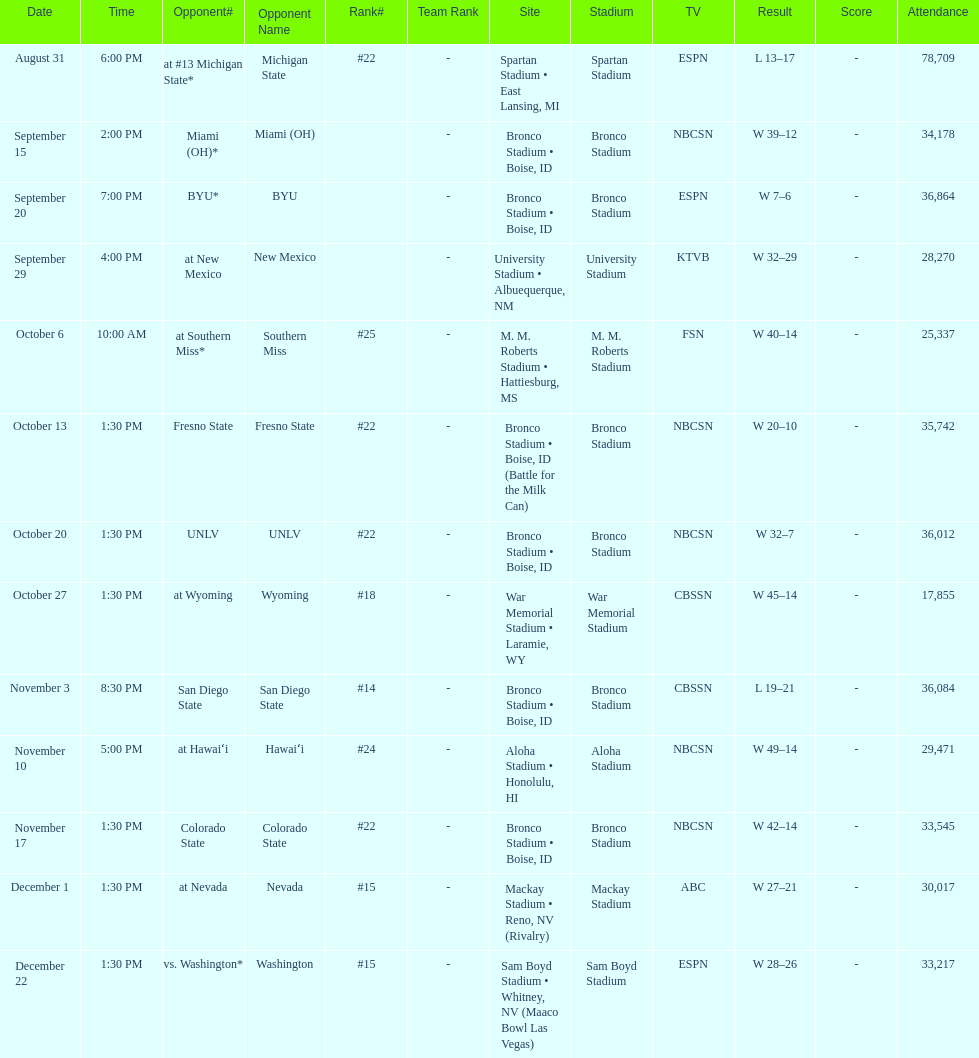Which team has the highest rank among those listed? San Diego State. 